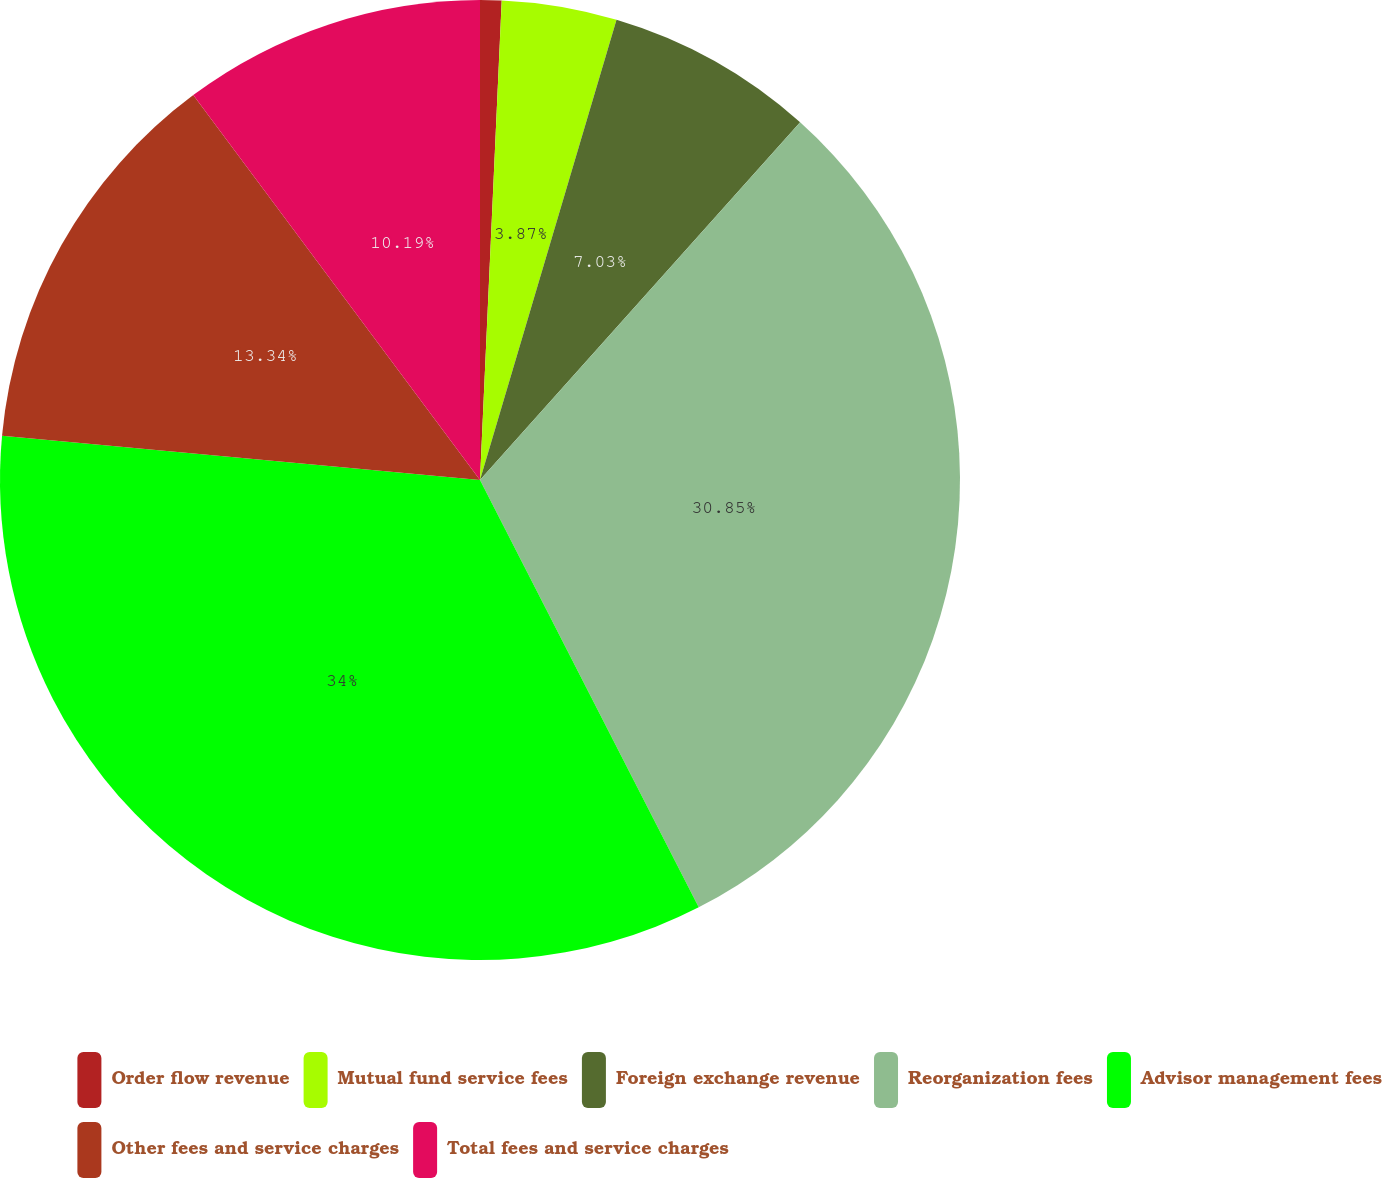Convert chart. <chart><loc_0><loc_0><loc_500><loc_500><pie_chart><fcel>Order flow revenue<fcel>Mutual fund service fees<fcel>Foreign exchange revenue<fcel>Reorganization fees<fcel>Advisor management fees<fcel>Other fees and service charges<fcel>Total fees and service charges<nl><fcel>0.72%<fcel>3.87%<fcel>7.03%<fcel>30.85%<fcel>34.0%<fcel>13.34%<fcel>10.19%<nl></chart> 